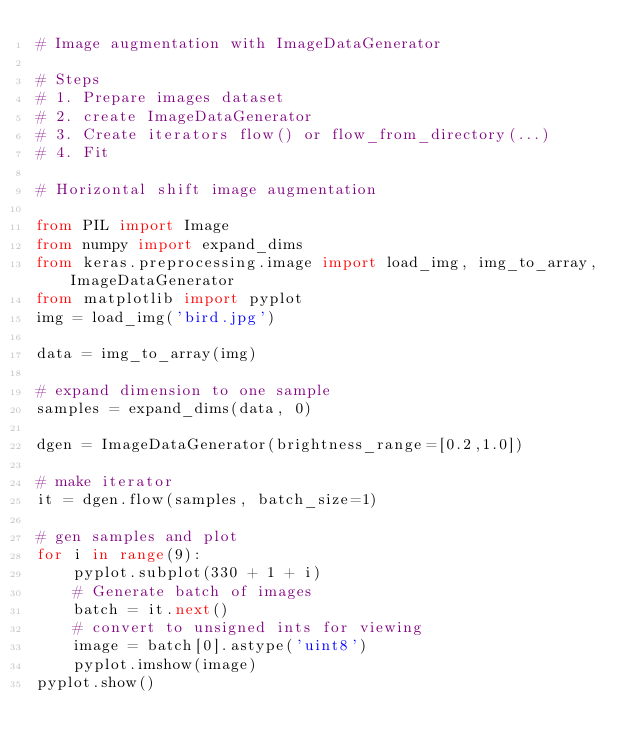<code> <loc_0><loc_0><loc_500><loc_500><_Python_># Image augmentation with ImageDataGenerator

# Steps
# 1. Prepare images dataset
# 2. create ImageDataGenerator
# 3. Create iterators flow() or flow_from_directory(...)
# 4. Fit 

# Horizontal shift image augmentation

from PIL import Image
from numpy import expand_dims
from keras.preprocessing.image import load_img, img_to_array, ImageDataGenerator
from matplotlib import pyplot
img = load_img('bird.jpg')

data = img_to_array(img)

# expand dimension to one sample
samples = expand_dims(data, 0)

dgen = ImageDataGenerator(brightness_range=[0.2,1.0])

# make iterator
it = dgen.flow(samples, batch_size=1)

# gen samples and plot
for i in range(9):
    pyplot.subplot(330 + 1 + i)
    # Generate batch of images
    batch = it.next()
    # convert to unsigned ints for viewing
    image = batch[0].astype('uint8')
    pyplot.imshow(image)
pyplot.show()
</code> 